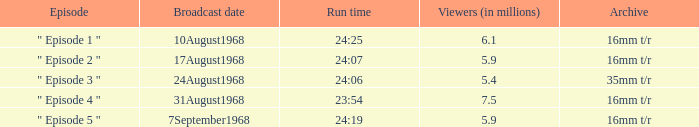How many episodes throughout history have a 24:06 runtime? 1.0. Write the full table. {'header': ['Episode', 'Broadcast date', 'Run time', 'Viewers (in millions)', 'Archive'], 'rows': [['" Episode 1 "', '10August1968', '24:25', '6.1', '16mm t/r'], ['" Episode 2 "', '17August1968', '24:07', '5.9', '16mm t/r'], ['" Episode 3 "', '24August1968', '24:06', '5.4', '35mm t/r'], ['" Episode 4 "', '31August1968', '23:54', '7.5', '16mm t/r'], ['" Episode 5 "', '7September1968', '24:19', '5.9', '16mm t/r']]} 